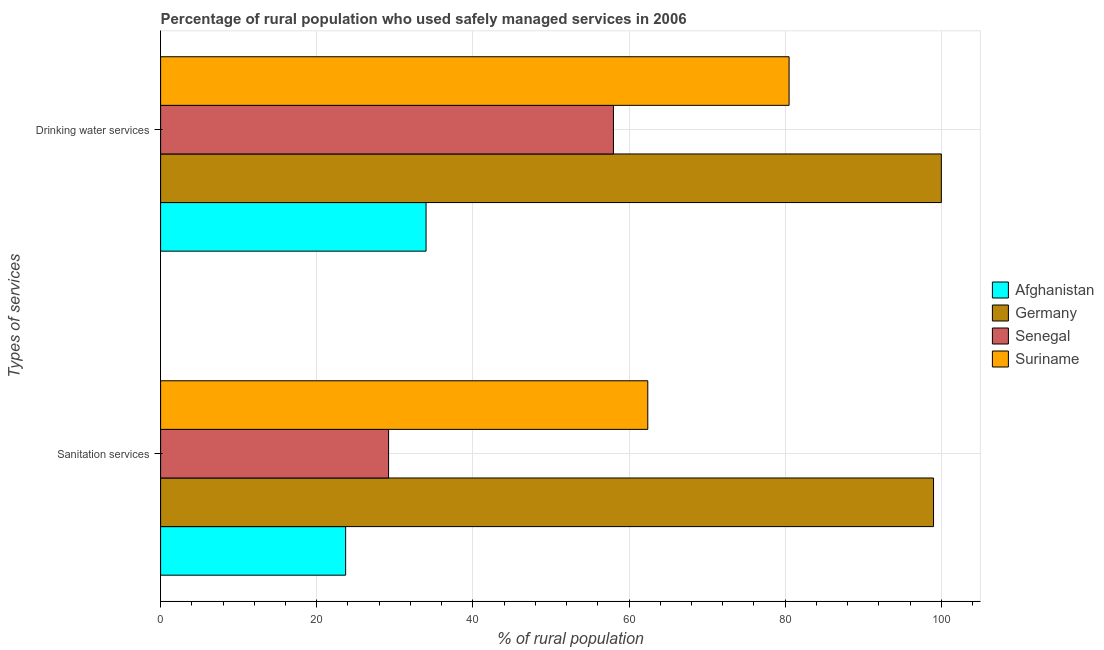How many groups of bars are there?
Make the answer very short. 2. Are the number of bars on each tick of the Y-axis equal?
Your answer should be very brief. Yes. How many bars are there on the 2nd tick from the bottom?
Keep it short and to the point. 4. What is the label of the 2nd group of bars from the top?
Provide a short and direct response. Sanitation services. What is the percentage of rural population who used sanitation services in Germany?
Your answer should be compact. 99. Across all countries, what is the maximum percentage of rural population who used sanitation services?
Provide a short and direct response. 99. Across all countries, what is the minimum percentage of rural population who used drinking water services?
Give a very brief answer. 34. In which country was the percentage of rural population who used sanitation services minimum?
Offer a terse response. Afghanistan. What is the total percentage of rural population who used drinking water services in the graph?
Provide a short and direct response. 272.5. What is the difference between the percentage of rural population who used sanitation services in Germany and that in Senegal?
Keep it short and to the point. 69.8. What is the difference between the percentage of rural population who used drinking water services in Senegal and the percentage of rural population who used sanitation services in Suriname?
Offer a terse response. -4.4. What is the average percentage of rural population who used sanitation services per country?
Provide a short and direct response. 53.58. In how many countries, is the percentage of rural population who used drinking water services greater than 92 %?
Give a very brief answer. 1. What is the ratio of the percentage of rural population who used drinking water services in Suriname to that in Senegal?
Keep it short and to the point. 1.39. What does the 2nd bar from the top in Drinking water services represents?
Offer a very short reply. Senegal. Are all the bars in the graph horizontal?
Provide a succinct answer. Yes. What is the difference between two consecutive major ticks on the X-axis?
Provide a short and direct response. 20. Are the values on the major ticks of X-axis written in scientific E-notation?
Your response must be concise. No. Does the graph contain any zero values?
Your response must be concise. No. Where does the legend appear in the graph?
Offer a terse response. Center right. How are the legend labels stacked?
Your response must be concise. Vertical. What is the title of the graph?
Provide a succinct answer. Percentage of rural population who used safely managed services in 2006. Does "Sub-Saharan Africa (developing only)" appear as one of the legend labels in the graph?
Make the answer very short. No. What is the label or title of the X-axis?
Your answer should be compact. % of rural population. What is the label or title of the Y-axis?
Keep it short and to the point. Types of services. What is the % of rural population in Afghanistan in Sanitation services?
Your answer should be very brief. 23.7. What is the % of rural population in Senegal in Sanitation services?
Offer a terse response. 29.2. What is the % of rural population in Suriname in Sanitation services?
Offer a terse response. 62.4. What is the % of rural population in Suriname in Drinking water services?
Provide a short and direct response. 80.5. Across all Types of services, what is the maximum % of rural population in Afghanistan?
Make the answer very short. 34. Across all Types of services, what is the maximum % of rural population in Suriname?
Provide a short and direct response. 80.5. Across all Types of services, what is the minimum % of rural population of Afghanistan?
Your response must be concise. 23.7. Across all Types of services, what is the minimum % of rural population of Germany?
Provide a short and direct response. 99. Across all Types of services, what is the minimum % of rural population in Senegal?
Give a very brief answer. 29.2. Across all Types of services, what is the minimum % of rural population in Suriname?
Give a very brief answer. 62.4. What is the total % of rural population of Afghanistan in the graph?
Give a very brief answer. 57.7. What is the total % of rural population in Germany in the graph?
Provide a succinct answer. 199. What is the total % of rural population in Senegal in the graph?
Offer a terse response. 87.2. What is the total % of rural population in Suriname in the graph?
Provide a succinct answer. 142.9. What is the difference between the % of rural population in Afghanistan in Sanitation services and that in Drinking water services?
Give a very brief answer. -10.3. What is the difference between the % of rural population in Senegal in Sanitation services and that in Drinking water services?
Offer a very short reply. -28.8. What is the difference between the % of rural population of Suriname in Sanitation services and that in Drinking water services?
Provide a short and direct response. -18.1. What is the difference between the % of rural population in Afghanistan in Sanitation services and the % of rural population in Germany in Drinking water services?
Your answer should be compact. -76.3. What is the difference between the % of rural population in Afghanistan in Sanitation services and the % of rural population in Senegal in Drinking water services?
Offer a terse response. -34.3. What is the difference between the % of rural population in Afghanistan in Sanitation services and the % of rural population in Suriname in Drinking water services?
Give a very brief answer. -56.8. What is the difference between the % of rural population of Germany in Sanitation services and the % of rural population of Senegal in Drinking water services?
Offer a very short reply. 41. What is the difference between the % of rural population in Senegal in Sanitation services and the % of rural population in Suriname in Drinking water services?
Give a very brief answer. -51.3. What is the average % of rural population in Afghanistan per Types of services?
Keep it short and to the point. 28.85. What is the average % of rural population in Germany per Types of services?
Offer a very short reply. 99.5. What is the average % of rural population in Senegal per Types of services?
Ensure brevity in your answer.  43.6. What is the average % of rural population of Suriname per Types of services?
Ensure brevity in your answer.  71.45. What is the difference between the % of rural population in Afghanistan and % of rural population in Germany in Sanitation services?
Make the answer very short. -75.3. What is the difference between the % of rural population in Afghanistan and % of rural population in Suriname in Sanitation services?
Provide a succinct answer. -38.7. What is the difference between the % of rural population of Germany and % of rural population of Senegal in Sanitation services?
Offer a terse response. 69.8. What is the difference between the % of rural population of Germany and % of rural population of Suriname in Sanitation services?
Give a very brief answer. 36.6. What is the difference between the % of rural population of Senegal and % of rural population of Suriname in Sanitation services?
Provide a succinct answer. -33.2. What is the difference between the % of rural population of Afghanistan and % of rural population of Germany in Drinking water services?
Keep it short and to the point. -66. What is the difference between the % of rural population of Afghanistan and % of rural population of Senegal in Drinking water services?
Offer a very short reply. -24. What is the difference between the % of rural population in Afghanistan and % of rural population in Suriname in Drinking water services?
Your response must be concise. -46.5. What is the difference between the % of rural population of Senegal and % of rural population of Suriname in Drinking water services?
Your response must be concise. -22.5. What is the ratio of the % of rural population of Afghanistan in Sanitation services to that in Drinking water services?
Your response must be concise. 0.7. What is the ratio of the % of rural population of Senegal in Sanitation services to that in Drinking water services?
Your response must be concise. 0.5. What is the ratio of the % of rural population of Suriname in Sanitation services to that in Drinking water services?
Keep it short and to the point. 0.78. What is the difference between the highest and the second highest % of rural population in Afghanistan?
Your answer should be compact. 10.3. What is the difference between the highest and the second highest % of rural population of Senegal?
Keep it short and to the point. 28.8. What is the difference between the highest and the lowest % of rural population in Senegal?
Your answer should be very brief. 28.8. 